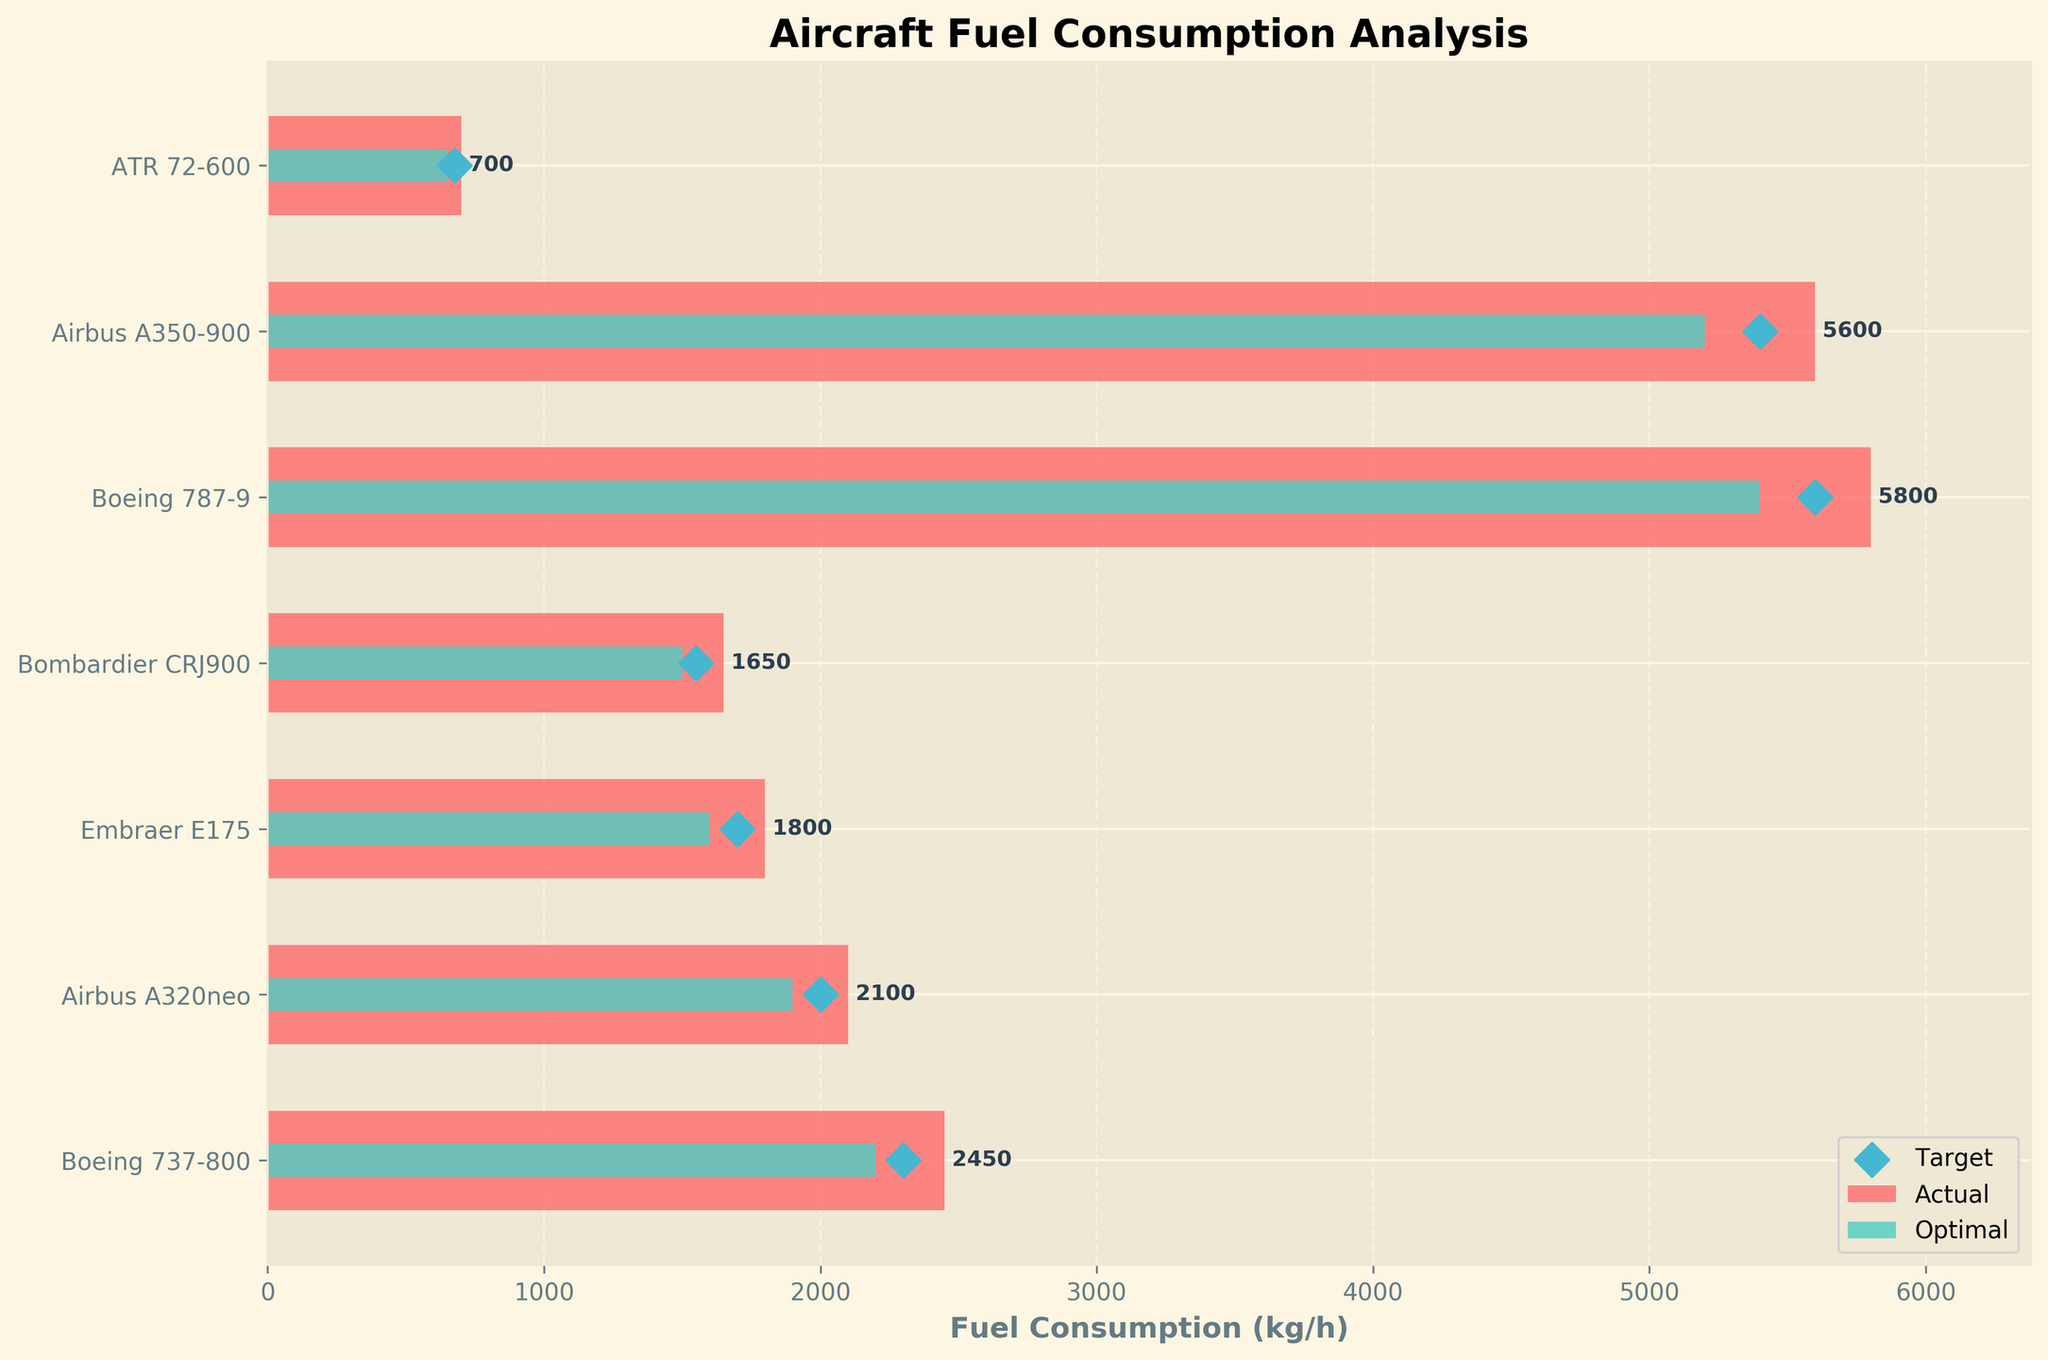What is the title of the plot? The plot has a title at the top which shows the purpose of the visualization. It reads 'Aircraft Fuel Consumption Analysis'.
Answer: Aircraft Fuel Consumption Analysis What color represents the actual fuel consumption bars? The horizontal bars that represent actual fuel consumption of different aircraft models are colored in a distinct shade. They are colored in a red or pinkish shade.
Answer: Red Which aircraft model has the highest actual fuel consumption? By comparing the length of the red bars, the bar corresponding to the Boeing 787-9 is the longest, indicating it consumes the most fuel.
Answer: Boeing 787-9 What is the optimal fuel consumption for the Airbus A350-900? The green bar that represents the optimal fuel consumption for the Airbus A350-900 is located, and its length corresponds to a value labeled 5200 kg/h.
Answer: 5200 kg/h How does the actual fuel consumption of the Bombardier CRJ900 compare to its target fuel consumption? The red bar representing the actual fuel consumption of the Bombardier CRJ900 is longer than the diamond marker representing its target, which indicates that the actual consumption is higher than the target of 1550 kg/h.
Answer: Higher Which aircraft model is closest to meeting its target fuel consumption? The comparison of the positions of the diamond markers and the lengths of the red bars shows that the ATR 72-600's actual fuel consumption bar is closest to its corresponding diamond marker, which represents the target.
Answer: ATR 72-600 What is the difference between the actual and optimal fuel consumption for the Boeing 737-800? Subtracting the optimal consumption (2200 kg/h) from the actual consumption (2450 kg/h) for the Boeing 737-800 gives the difference: 2450 - 2200 = 250 kg/h.
Answer: 250 kg/h Which aircraft's actual fuel consumption is within its optimal range and how much difference does it have from its target? Checking for the green bar's length being equal to or greater than the red bar's length and then comparing the red bar with the diamond marker shows that no aircraft has its actual consumption within its optimal range.
Answer: None What's the total actual fuel consumption for all listed aircraft models? Summing up all the values of the red bars for each aircraft model: 2450 + 2100 + 1800 + 1650 + 5800 + 5600 + 700 equals to 20,100 kg/h.
Answer: 20,100 kg/h Is any aircraft's actual fuel consumption equal to its target fuel consumption? Comparing the length of any red bar to its corresponding diamond marker shows that none of the aircraft models have their actual consumption equal to their target fuel consumption.
Answer: No 